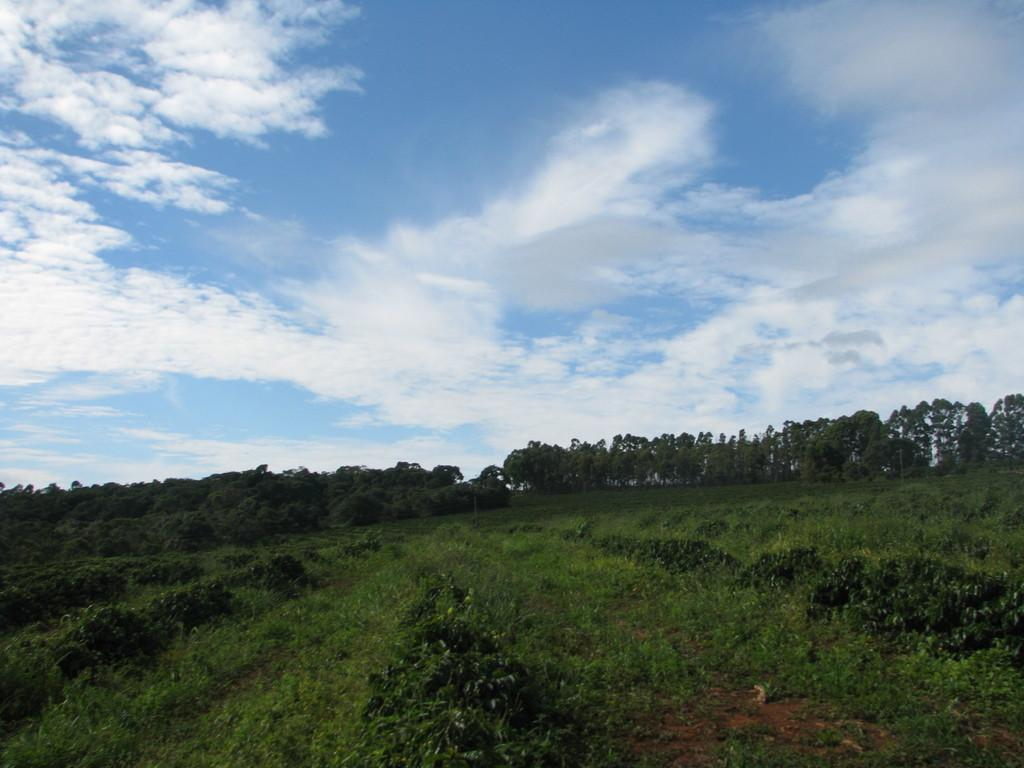What type of vegetation can be seen in the image? There are plants and trees in the image. Can you describe the sky in the image? There are clouds visible in the image. What type of reaction can be seen in the image? There is no reaction visible in the image; it only contains plants, trees, and clouds. 